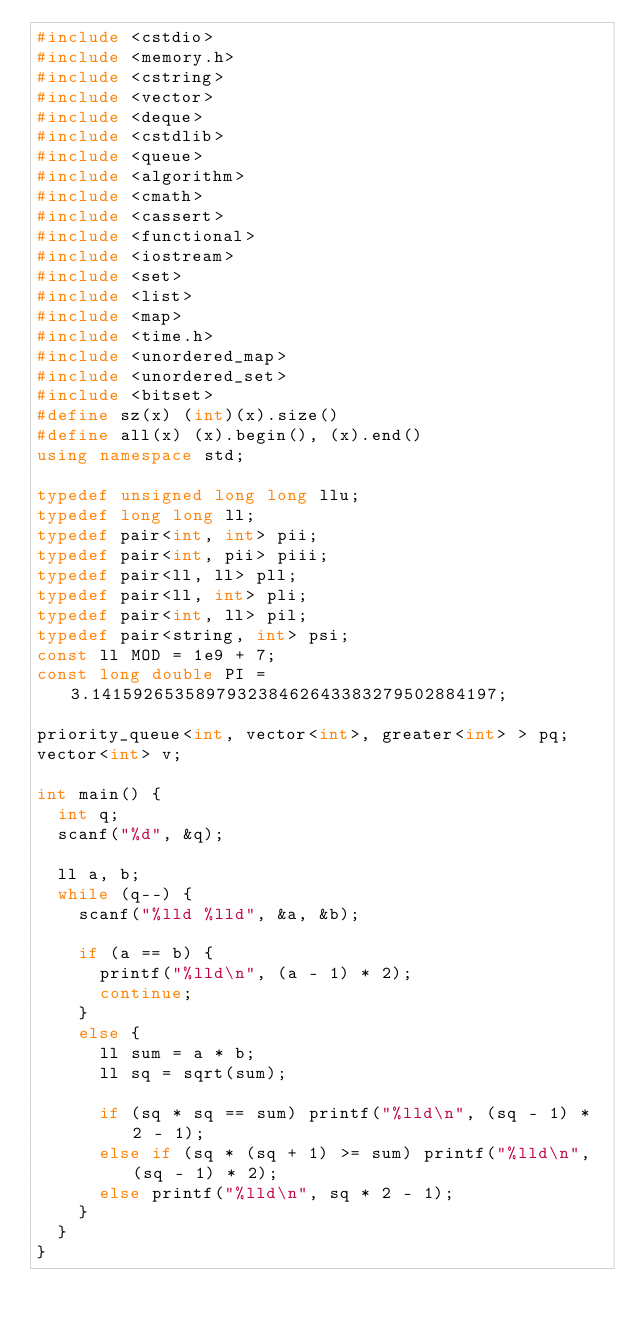<code> <loc_0><loc_0><loc_500><loc_500><_C++_>#include <cstdio>
#include <memory.h>
#include <cstring>
#include <vector>
#include <deque>
#include <cstdlib>
#include <queue>
#include <algorithm>
#include <cmath>
#include <cassert>
#include <functional>
#include <iostream>
#include <set>
#include <list>
#include <map>
#include <time.h>
#include <unordered_map>
#include <unordered_set>
#include <bitset>
#define sz(x) (int)(x).size()
#define all(x) (x).begin(), (x).end()
using namespace std;

typedef unsigned long long llu;
typedef long long ll;
typedef pair<int, int> pii;
typedef pair<int, pii> piii;
typedef pair<ll, ll> pll;
typedef pair<ll, int> pli;
typedef pair<int, ll> pil;
typedef pair<string, int> psi;
const ll MOD = 1e9 + 7;
const long double PI = 3.141592653589793238462643383279502884197;

priority_queue<int, vector<int>, greater<int> > pq;
vector<int> v;

int main() {
	int q;
	scanf("%d", &q);

	ll a, b;
	while (q--) {
		scanf("%lld %lld", &a, &b);

		if (a == b) {
			printf("%lld\n", (a - 1) * 2);
			continue;
		}
		else {
			ll sum = a * b;
			ll sq = sqrt(sum);

			if (sq * sq == sum) printf("%lld\n", (sq - 1) * 2 - 1);
			else if (sq * (sq + 1) >= sum) printf("%lld\n", (sq - 1) * 2);
			else printf("%lld\n", sq * 2 - 1);
		}
	}
}
</code> 